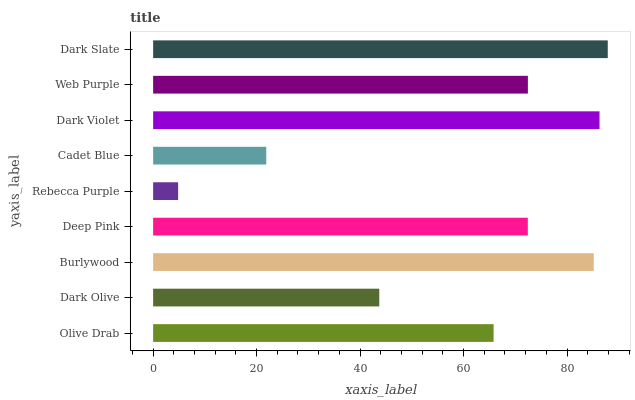Is Rebecca Purple the minimum?
Answer yes or no. Yes. Is Dark Slate the maximum?
Answer yes or no. Yes. Is Dark Olive the minimum?
Answer yes or no. No. Is Dark Olive the maximum?
Answer yes or no. No. Is Olive Drab greater than Dark Olive?
Answer yes or no. Yes. Is Dark Olive less than Olive Drab?
Answer yes or no. Yes. Is Dark Olive greater than Olive Drab?
Answer yes or no. No. Is Olive Drab less than Dark Olive?
Answer yes or no. No. Is Deep Pink the high median?
Answer yes or no. Yes. Is Deep Pink the low median?
Answer yes or no. Yes. Is Cadet Blue the high median?
Answer yes or no. No. Is Web Purple the low median?
Answer yes or no. No. 